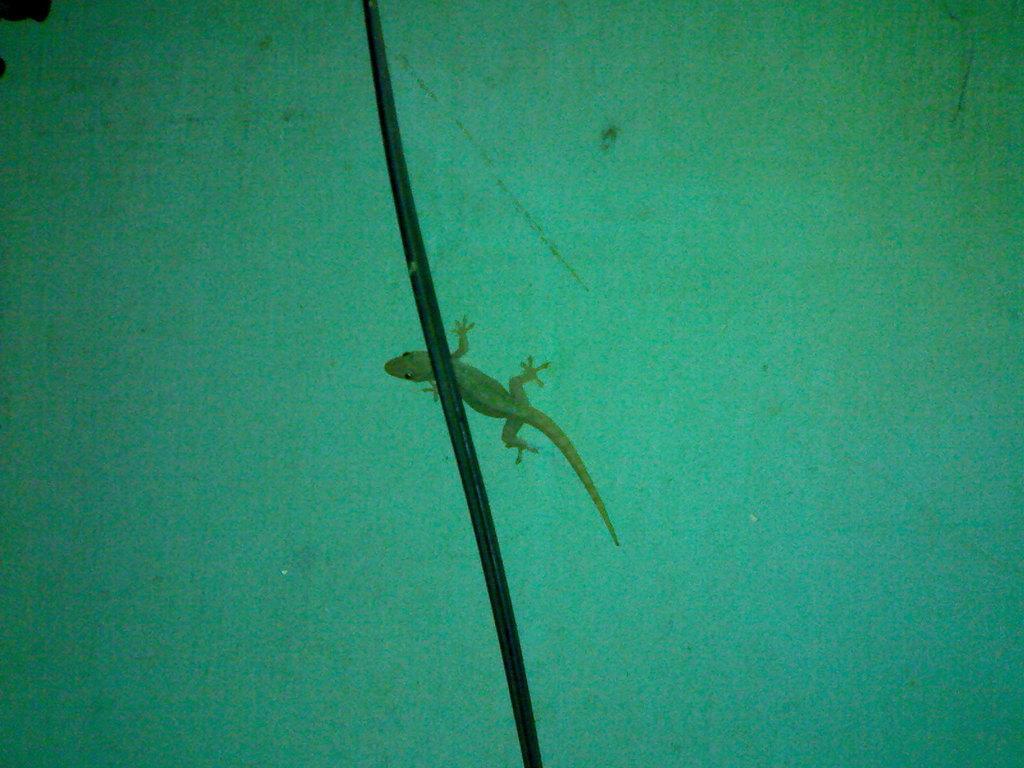Can you describe this image briefly? In this image there is a lizard on the wall, in front of the lizard there is a cable. 